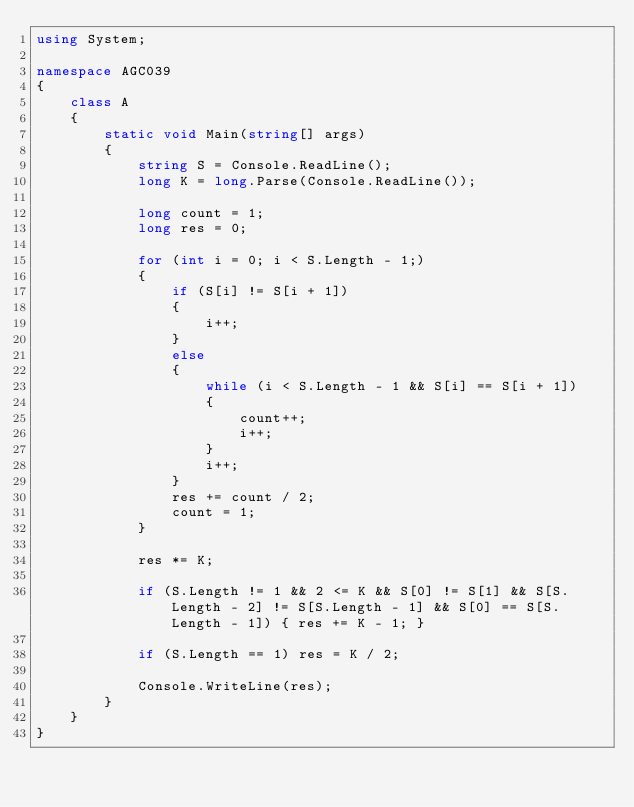Convert code to text. <code><loc_0><loc_0><loc_500><loc_500><_C#_>using System;

namespace AGC039
{
    class A
    {
        static void Main(string[] args)
        {
            string S = Console.ReadLine();
            long K = long.Parse(Console.ReadLine());

            long count = 1;
            long res = 0;

            for (int i = 0; i < S.Length - 1;)
            {
                if (S[i] != S[i + 1])
                {
                    i++;
                }
                else
                {
                    while (i < S.Length - 1 && S[i] == S[i + 1])
                    {
                        count++;
                        i++;
                    }
                    i++;
                }
                res += count / 2;
                count = 1;
            }

            res *= K;

            if (S.Length != 1 && 2 <= K && S[0] != S[1] && S[S.Length - 2] != S[S.Length - 1] && S[0] == S[S.Length - 1]) { res += K - 1; }

            if (S.Length == 1) res = K / 2;

            Console.WriteLine(res);
        }
    }
}
</code> 